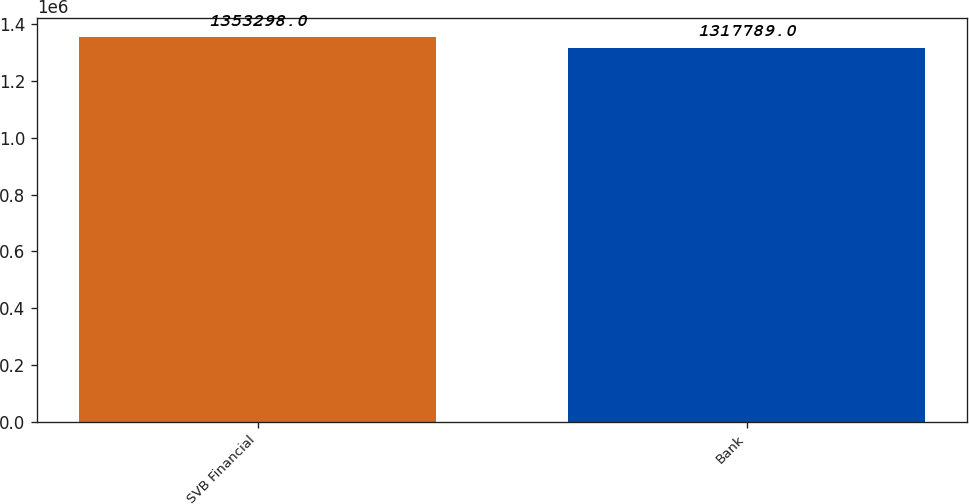Convert chart to OTSL. <chart><loc_0><loc_0><loc_500><loc_500><bar_chart><fcel>SVB Financial<fcel>Bank<nl><fcel>1.3533e+06<fcel>1.31779e+06<nl></chart> 